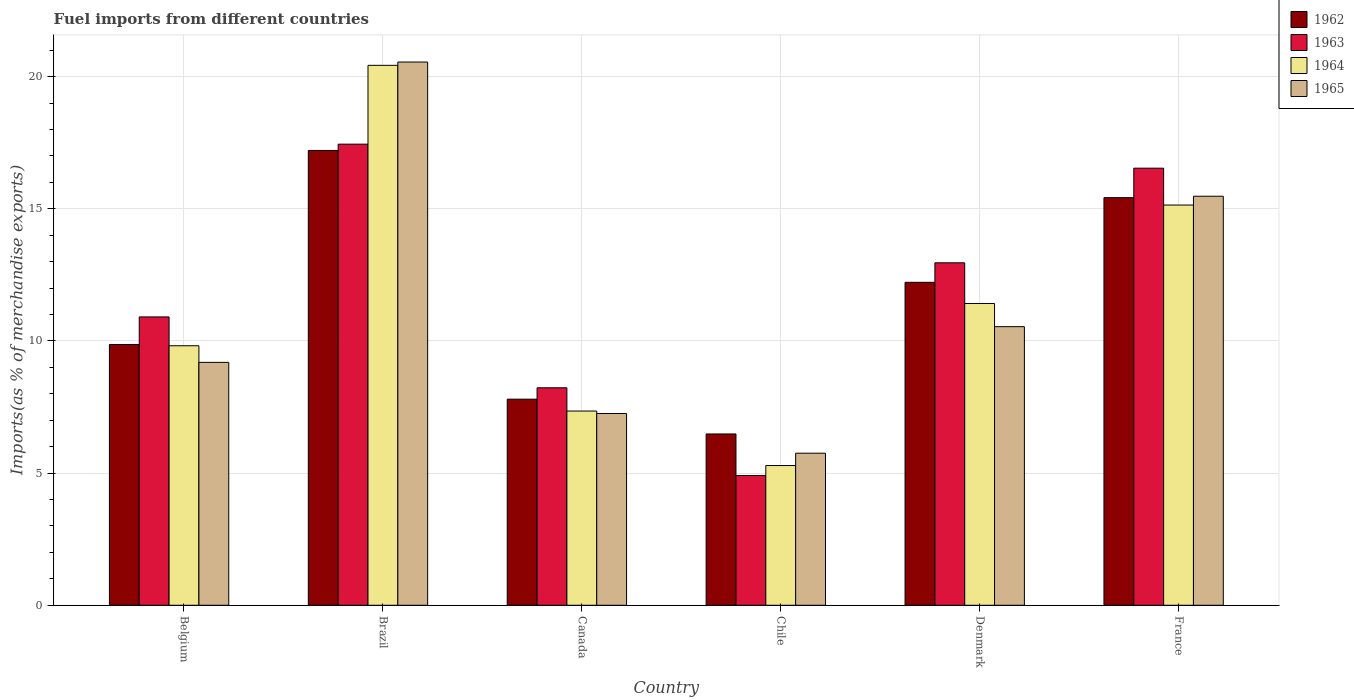How many different coloured bars are there?
Your answer should be compact. 4. Are the number of bars per tick equal to the number of legend labels?
Make the answer very short. Yes. How many bars are there on the 3rd tick from the left?
Your answer should be very brief. 4. What is the percentage of imports to different countries in 1964 in Brazil?
Offer a terse response. 20.43. Across all countries, what is the maximum percentage of imports to different countries in 1964?
Your answer should be very brief. 20.43. Across all countries, what is the minimum percentage of imports to different countries in 1962?
Give a very brief answer. 6.48. In which country was the percentage of imports to different countries in 1965 minimum?
Keep it short and to the point. Chile. What is the total percentage of imports to different countries in 1962 in the graph?
Offer a very short reply. 69. What is the difference between the percentage of imports to different countries in 1965 in Chile and that in France?
Your response must be concise. -9.72. What is the difference between the percentage of imports to different countries in 1963 in France and the percentage of imports to different countries in 1962 in Belgium?
Offer a very short reply. 6.67. What is the average percentage of imports to different countries in 1965 per country?
Offer a very short reply. 11.46. What is the difference between the percentage of imports to different countries of/in 1964 and percentage of imports to different countries of/in 1962 in Chile?
Provide a short and direct response. -1.19. What is the ratio of the percentage of imports to different countries in 1965 in Canada to that in France?
Provide a succinct answer. 0.47. Is the difference between the percentage of imports to different countries in 1964 in Belgium and Canada greater than the difference between the percentage of imports to different countries in 1962 in Belgium and Canada?
Make the answer very short. Yes. What is the difference between the highest and the second highest percentage of imports to different countries in 1962?
Provide a short and direct response. 4.99. What is the difference between the highest and the lowest percentage of imports to different countries in 1964?
Provide a succinct answer. 15.14. In how many countries, is the percentage of imports to different countries in 1963 greater than the average percentage of imports to different countries in 1963 taken over all countries?
Offer a terse response. 3. What does the 3rd bar from the left in Belgium represents?
Ensure brevity in your answer.  1964. What does the 2nd bar from the right in Canada represents?
Offer a very short reply. 1964. Is it the case that in every country, the sum of the percentage of imports to different countries in 1962 and percentage of imports to different countries in 1965 is greater than the percentage of imports to different countries in 1964?
Give a very brief answer. Yes. How many bars are there?
Your answer should be very brief. 24. Are all the bars in the graph horizontal?
Provide a short and direct response. No. How many countries are there in the graph?
Your answer should be compact. 6. Does the graph contain any zero values?
Your response must be concise. No. Does the graph contain grids?
Keep it short and to the point. Yes. Where does the legend appear in the graph?
Your answer should be very brief. Top right. How are the legend labels stacked?
Keep it short and to the point. Vertical. What is the title of the graph?
Keep it short and to the point. Fuel imports from different countries. Does "1991" appear as one of the legend labels in the graph?
Provide a succinct answer. No. What is the label or title of the Y-axis?
Give a very brief answer. Imports(as % of merchandise exports). What is the Imports(as % of merchandise exports) in 1962 in Belgium?
Offer a terse response. 9.87. What is the Imports(as % of merchandise exports) in 1963 in Belgium?
Keep it short and to the point. 10.91. What is the Imports(as % of merchandise exports) in 1964 in Belgium?
Keep it short and to the point. 9.82. What is the Imports(as % of merchandise exports) in 1965 in Belgium?
Keep it short and to the point. 9.19. What is the Imports(as % of merchandise exports) of 1962 in Brazil?
Offer a very short reply. 17.21. What is the Imports(as % of merchandise exports) of 1963 in Brazil?
Give a very brief answer. 17.45. What is the Imports(as % of merchandise exports) in 1964 in Brazil?
Make the answer very short. 20.43. What is the Imports(as % of merchandise exports) in 1965 in Brazil?
Give a very brief answer. 20.55. What is the Imports(as % of merchandise exports) in 1962 in Canada?
Offer a very short reply. 7.8. What is the Imports(as % of merchandise exports) in 1963 in Canada?
Keep it short and to the point. 8.23. What is the Imports(as % of merchandise exports) of 1964 in Canada?
Your answer should be very brief. 7.35. What is the Imports(as % of merchandise exports) of 1965 in Canada?
Your response must be concise. 7.26. What is the Imports(as % of merchandise exports) in 1962 in Chile?
Offer a terse response. 6.48. What is the Imports(as % of merchandise exports) in 1963 in Chile?
Keep it short and to the point. 4.91. What is the Imports(as % of merchandise exports) in 1964 in Chile?
Offer a terse response. 5.29. What is the Imports(as % of merchandise exports) in 1965 in Chile?
Provide a succinct answer. 5.75. What is the Imports(as % of merchandise exports) in 1962 in Denmark?
Your response must be concise. 12.22. What is the Imports(as % of merchandise exports) in 1963 in Denmark?
Your answer should be very brief. 12.96. What is the Imports(as % of merchandise exports) in 1964 in Denmark?
Your answer should be very brief. 11.42. What is the Imports(as % of merchandise exports) in 1965 in Denmark?
Your answer should be very brief. 10.54. What is the Imports(as % of merchandise exports) of 1962 in France?
Make the answer very short. 15.42. What is the Imports(as % of merchandise exports) in 1963 in France?
Make the answer very short. 16.54. What is the Imports(as % of merchandise exports) in 1964 in France?
Give a very brief answer. 15.14. What is the Imports(as % of merchandise exports) of 1965 in France?
Provide a short and direct response. 15.48. Across all countries, what is the maximum Imports(as % of merchandise exports) in 1962?
Give a very brief answer. 17.21. Across all countries, what is the maximum Imports(as % of merchandise exports) in 1963?
Offer a very short reply. 17.45. Across all countries, what is the maximum Imports(as % of merchandise exports) of 1964?
Your response must be concise. 20.43. Across all countries, what is the maximum Imports(as % of merchandise exports) of 1965?
Provide a succinct answer. 20.55. Across all countries, what is the minimum Imports(as % of merchandise exports) in 1962?
Keep it short and to the point. 6.48. Across all countries, what is the minimum Imports(as % of merchandise exports) of 1963?
Offer a terse response. 4.91. Across all countries, what is the minimum Imports(as % of merchandise exports) of 1964?
Give a very brief answer. 5.29. Across all countries, what is the minimum Imports(as % of merchandise exports) in 1965?
Make the answer very short. 5.75. What is the total Imports(as % of merchandise exports) of 1962 in the graph?
Provide a short and direct response. 69. What is the total Imports(as % of merchandise exports) of 1963 in the graph?
Offer a terse response. 70.99. What is the total Imports(as % of merchandise exports) of 1964 in the graph?
Ensure brevity in your answer.  69.45. What is the total Imports(as % of merchandise exports) of 1965 in the graph?
Provide a succinct answer. 68.77. What is the difference between the Imports(as % of merchandise exports) in 1962 in Belgium and that in Brazil?
Your answer should be compact. -7.34. What is the difference between the Imports(as % of merchandise exports) of 1963 in Belgium and that in Brazil?
Provide a short and direct response. -6.54. What is the difference between the Imports(as % of merchandise exports) in 1964 in Belgium and that in Brazil?
Keep it short and to the point. -10.61. What is the difference between the Imports(as % of merchandise exports) of 1965 in Belgium and that in Brazil?
Your answer should be very brief. -11.36. What is the difference between the Imports(as % of merchandise exports) of 1962 in Belgium and that in Canada?
Provide a succinct answer. 2.07. What is the difference between the Imports(as % of merchandise exports) of 1963 in Belgium and that in Canada?
Give a very brief answer. 2.68. What is the difference between the Imports(as % of merchandise exports) of 1964 in Belgium and that in Canada?
Your response must be concise. 2.47. What is the difference between the Imports(as % of merchandise exports) in 1965 in Belgium and that in Canada?
Ensure brevity in your answer.  1.93. What is the difference between the Imports(as % of merchandise exports) in 1962 in Belgium and that in Chile?
Provide a succinct answer. 3.39. What is the difference between the Imports(as % of merchandise exports) of 1963 in Belgium and that in Chile?
Give a very brief answer. 6. What is the difference between the Imports(as % of merchandise exports) in 1964 in Belgium and that in Chile?
Make the answer very short. 4.53. What is the difference between the Imports(as % of merchandise exports) in 1965 in Belgium and that in Chile?
Keep it short and to the point. 3.44. What is the difference between the Imports(as % of merchandise exports) of 1962 in Belgium and that in Denmark?
Provide a short and direct response. -2.35. What is the difference between the Imports(as % of merchandise exports) in 1963 in Belgium and that in Denmark?
Give a very brief answer. -2.05. What is the difference between the Imports(as % of merchandise exports) of 1964 in Belgium and that in Denmark?
Keep it short and to the point. -1.6. What is the difference between the Imports(as % of merchandise exports) of 1965 in Belgium and that in Denmark?
Ensure brevity in your answer.  -1.35. What is the difference between the Imports(as % of merchandise exports) of 1962 in Belgium and that in France?
Your response must be concise. -5.56. What is the difference between the Imports(as % of merchandise exports) of 1963 in Belgium and that in France?
Ensure brevity in your answer.  -5.63. What is the difference between the Imports(as % of merchandise exports) in 1964 in Belgium and that in France?
Offer a terse response. -5.32. What is the difference between the Imports(as % of merchandise exports) of 1965 in Belgium and that in France?
Provide a succinct answer. -6.29. What is the difference between the Imports(as % of merchandise exports) of 1962 in Brazil and that in Canada?
Your answer should be very brief. 9.41. What is the difference between the Imports(as % of merchandise exports) in 1963 in Brazil and that in Canada?
Provide a succinct answer. 9.22. What is the difference between the Imports(as % of merchandise exports) in 1964 in Brazil and that in Canada?
Offer a terse response. 13.08. What is the difference between the Imports(as % of merchandise exports) of 1965 in Brazil and that in Canada?
Your answer should be compact. 13.3. What is the difference between the Imports(as % of merchandise exports) in 1962 in Brazil and that in Chile?
Your response must be concise. 10.73. What is the difference between the Imports(as % of merchandise exports) in 1963 in Brazil and that in Chile?
Keep it short and to the point. 12.54. What is the difference between the Imports(as % of merchandise exports) in 1964 in Brazil and that in Chile?
Ensure brevity in your answer.  15.14. What is the difference between the Imports(as % of merchandise exports) in 1965 in Brazil and that in Chile?
Keep it short and to the point. 14.8. What is the difference between the Imports(as % of merchandise exports) in 1962 in Brazil and that in Denmark?
Your response must be concise. 4.99. What is the difference between the Imports(as % of merchandise exports) of 1963 in Brazil and that in Denmark?
Offer a very short reply. 4.49. What is the difference between the Imports(as % of merchandise exports) of 1964 in Brazil and that in Denmark?
Offer a very short reply. 9.01. What is the difference between the Imports(as % of merchandise exports) in 1965 in Brazil and that in Denmark?
Provide a short and direct response. 10.01. What is the difference between the Imports(as % of merchandise exports) in 1962 in Brazil and that in France?
Your answer should be compact. 1.79. What is the difference between the Imports(as % of merchandise exports) of 1963 in Brazil and that in France?
Offer a terse response. 0.91. What is the difference between the Imports(as % of merchandise exports) in 1964 in Brazil and that in France?
Keep it short and to the point. 5.29. What is the difference between the Imports(as % of merchandise exports) in 1965 in Brazil and that in France?
Offer a terse response. 5.08. What is the difference between the Imports(as % of merchandise exports) in 1962 in Canada and that in Chile?
Your response must be concise. 1.32. What is the difference between the Imports(as % of merchandise exports) of 1963 in Canada and that in Chile?
Give a very brief answer. 3.32. What is the difference between the Imports(as % of merchandise exports) in 1964 in Canada and that in Chile?
Make the answer very short. 2.06. What is the difference between the Imports(as % of merchandise exports) of 1965 in Canada and that in Chile?
Provide a succinct answer. 1.5. What is the difference between the Imports(as % of merchandise exports) of 1962 in Canada and that in Denmark?
Make the answer very short. -4.42. What is the difference between the Imports(as % of merchandise exports) in 1963 in Canada and that in Denmark?
Offer a very short reply. -4.73. What is the difference between the Imports(as % of merchandise exports) in 1964 in Canada and that in Denmark?
Give a very brief answer. -4.07. What is the difference between the Imports(as % of merchandise exports) of 1965 in Canada and that in Denmark?
Offer a terse response. -3.29. What is the difference between the Imports(as % of merchandise exports) of 1962 in Canada and that in France?
Ensure brevity in your answer.  -7.62. What is the difference between the Imports(as % of merchandise exports) in 1963 in Canada and that in France?
Your response must be concise. -8.31. What is the difference between the Imports(as % of merchandise exports) of 1964 in Canada and that in France?
Offer a terse response. -7.79. What is the difference between the Imports(as % of merchandise exports) of 1965 in Canada and that in France?
Your response must be concise. -8.22. What is the difference between the Imports(as % of merchandise exports) in 1962 in Chile and that in Denmark?
Your response must be concise. -5.74. What is the difference between the Imports(as % of merchandise exports) of 1963 in Chile and that in Denmark?
Provide a succinct answer. -8.05. What is the difference between the Imports(as % of merchandise exports) of 1964 in Chile and that in Denmark?
Keep it short and to the point. -6.13. What is the difference between the Imports(as % of merchandise exports) of 1965 in Chile and that in Denmark?
Offer a very short reply. -4.79. What is the difference between the Imports(as % of merchandise exports) in 1962 in Chile and that in France?
Give a very brief answer. -8.94. What is the difference between the Imports(as % of merchandise exports) in 1963 in Chile and that in France?
Give a very brief answer. -11.63. What is the difference between the Imports(as % of merchandise exports) of 1964 in Chile and that in France?
Make the answer very short. -9.86. What is the difference between the Imports(as % of merchandise exports) in 1965 in Chile and that in France?
Keep it short and to the point. -9.72. What is the difference between the Imports(as % of merchandise exports) in 1962 in Denmark and that in France?
Keep it short and to the point. -3.2. What is the difference between the Imports(as % of merchandise exports) of 1963 in Denmark and that in France?
Your answer should be compact. -3.58. What is the difference between the Imports(as % of merchandise exports) in 1964 in Denmark and that in France?
Keep it short and to the point. -3.72. What is the difference between the Imports(as % of merchandise exports) in 1965 in Denmark and that in France?
Provide a succinct answer. -4.94. What is the difference between the Imports(as % of merchandise exports) in 1962 in Belgium and the Imports(as % of merchandise exports) in 1963 in Brazil?
Ensure brevity in your answer.  -7.58. What is the difference between the Imports(as % of merchandise exports) in 1962 in Belgium and the Imports(as % of merchandise exports) in 1964 in Brazil?
Offer a terse response. -10.56. What is the difference between the Imports(as % of merchandise exports) in 1962 in Belgium and the Imports(as % of merchandise exports) in 1965 in Brazil?
Offer a terse response. -10.69. What is the difference between the Imports(as % of merchandise exports) of 1963 in Belgium and the Imports(as % of merchandise exports) of 1964 in Brazil?
Make the answer very short. -9.52. What is the difference between the Imports(as % of merchandise exports) of 1963 in Belgium and the Imports(as % of merchandise exports) of 1965 in Brazil?
Ensure brevity in your answer.  -9.64. What is the difference between the Imports(as % of merchandise exports) in 1964 in Belgium and the Imports(as % of merchandise exports) in 1965 in Brazil?
Your answer should be very brief. -10.74. What is the difference between the Imports(as % of merchandise exports) in 1962 in Belgium and the Imports(as % of merchandise exports) in 1963 in Canada?
Ensure brevity in your answer.  1.64. What is the difference between the Imports(as % of merchandise exports) of 1962 in Belgium and the Imports(as % of merchandise exports) of 1964 in Canada?
Offer a very short reply. 2.52. What is the difference between the Imports(as % of merchandise exports) in 1962 in Belgium and the Imports(as % of merchandise exports) in 1965 in Canada?
Offer a very short reply. 2.61. What is the difference between the Imports(as % of merchandise exports) of 1963 in Belgium and the Imports(as % of merchandise exports) of 1964 in Canada?
Your answer should be compact. 3.56. What is the difference between the Imports(as % of merchandise exports) of 1963 in Belgium and the Imports(as % of merchandise exports) of 1965 in Canada?
Provide a short and direct response. 3.65. What is the difference between the Imports(as % of merchandise exports) in 1964 in Belgium and the Imports(as % of merchandise exports) in 1965 in Canada?
Your answer should be compact. 2.56. What is the difference between the Imports(as % of merchandise exports) of 1962 in Belgium and the Imports(as % of merchandise exports) of 1963 in Chile?
Your answer should be compact. 4.96. What is the difference between the Imports(as % of merchandise exports) in 1962 in Belgium and the Imports(as % of merchandise exports) in 1964 in Chile?
Ensure brevity in your answer.  4.58. What is the difference between the Imports(as % of merchandise exports) in 1962 in Belgium and the Imports(as % of merchandise exports) in 1965 in Chile?
Ensure brevity in your answer.  4.11. What is the difference between the Imports(as % of merchandise exports) in 1963 in Belgium and the Imports(as % of merchandise exports) in 1964 in Chile?
Provide a short and direct response. 5.62. What is the difference between the Imports(as % of merchandise exports) of 1963 in Belgium and the Imports(as % of merchandise exports) of 1965 in Chile?
Your answer should be compact. 5.16. What is the difference between the Imports(as % of merchandise exports) in 1964 in Belgium and the Imports(as % of merchandise exports) in 1965 in Chile?
Your answer should be compact. 4.07. What is the difference between the Imports(as % of merchandise exports) in 1962 in Belgium and the Imports(as % of merchandise exports) in 1963 in Denmark?
Give a very brief answer. -3.09. What is the difference between the Imports(as % of merchandise exports) of 1962 in Belgium and the Imports(as % of merchandise exports) of 1964 in Denmark?
Provide a short and direct response. -1.55. What is the difference between the Imports(as % of merchandise exports) in 1962 in Belgium and the Imports(as % of merchandise exports) in 1965 in Denmark?
Provide a short and direct response. -0.67. What is the difference between the Imports(as % of merchandise exports) of 1963 in Belgium and the Imports(as % of merchandise exports) of 1964 in Denmark?
Make the answer very short. -0.51. What is the difference between the Imports(as % of merchandise exports) in 1963 in Belgium and the Imports(as % of merchandise exports) in 1965 in Denmark?
Ensure brevity in your answer.  0.37. What is the difference between the Imports(as % of merchandise exports) of 1964 in Belgium and the Imports(as % of merchandise exports) of 1965 in Denmark?
Keep it short and to the point. -0.72. What is the difference between the Imports(as % of merchandise exports) in 1962 in Belgium and the Imports(as % of merchandise exports) in 1963 in France?
Provide a short and direct response. -6.67. What is the difference between the Imports(as % of merchandise exports) of 1962 in Belgium and the Imports(as % of merchandise exports) of 1964 in France?
Your response must be concise. -5.28. What is the difference between the Imports(as % of merchandise exports) of 1962 in Belgium and the Imports(as % of merchandise exports) of 1965 in France?
Make the answer very short. -5.61. What is the difference between the Imports(as % of merchandise exports) in 1963 in Belgium and the Imports(as % of merchandise exports) in 1964 in France?
Make the answer very short. -4.23. What is the difference between the Imports(as % of merchandise exports) of 1963 in Belgium and the Imports(as % of merchandise exports) of 1965 in France?
Offer a very short reply. -4.57. What is the difference between the Imports(as % of merchandise exports) in 1964 in Belgium and the Imports(as % of merchandise exports) in 1965 in France?
Your response must be concise. -5.66. What is the difference between the Imports(as % of merchandise exports) in 1962 in Brazil and the Imports(as % of merchandise exports) in 1963 in Canada?
Keep it short and to the point. 8.98. What is the difference between the Imports(as % of merchandise exports) in 1962 in Brazil and the Imports(as % of merchandise exports) in 1964 in Canada?
Provide a short and direct response. 9.86. What is the difference between the Imports(as % of merchandise exports) in 1962 in Brazil and the Imports(as % of merchandise exports) in 1965 in Canada?
Offer a terse response. 9.95. What is the difference between the Imports(as % of merchandise exports) in 1963 in Brazil and the Imports(as % of merchandise exports) in 1964 in Canada?
Offer a terse response. 10.1. What is the difference between the Imports(as % of merchandise exports) of 1963 in Brazil and the Imports(as % of merchandise exports) of 1965 in Canada?
Make the answer very short. 10.19. What is the difference between the Imports(as % of merchandise exports) in 1964 in Brazil and the Imports(as % of merchandise exports) in 1965 in Canada?
Your answer should be compact. 13.17. What is the difference between the Imports(as % of merchandise exports) in 1962 in Brazil and the Imports(as % of merchandise exports) in 1963 in Chile?
Give a very brief answer. 12.3. What is the difference between the Imports(as % of merchandise exports) in 1962 in Brazil and the Imports(as % of merchandise exports) in 1964 in Chile?
Your answer should be compact. 11.92. What is the difference between the Imports(as % of merchandise exports) of 1962 in Brazil and the Imports(as % of merchandise exports) of 1965 in Chile?
Offer a terse response. 11.46. What is the difference between the Imports(as % of merchandise exports) of 1963 in Brazil and the Imports(as % of merchandise exports) of 1964 in Chile?
Make the answer very short. 12.16. What is the difference between the Imports(as % of merchandise exports) in 1963 in Brazil and the Imports(as % of merchandise exports) in 1965 in Chile?
Ensure brevity in your answer.  11.69. What is the difference between the Imports(as % of merchandise exports) in 1964 in Brazil and the Imports(as % of merchandise exports) in 1965 in Chile?
Your response must be concise. 14.68. What is the difference between the Imports(as % of merchandise exports) in 1962 in Brazil and the Imports(as % of merchandise exports) in 1963 in Denmark?
Offer a terse response. 4.25. What is the difference between the Imports(as % of merchandise exports) in 1962 in Brazil and the Imports(as % of merchandise exports) in 1964 in Denmark?
Keep it short and to the point. 5.79. What is the difference between the Imports(as % of merchandise exports) in 1962 in Brazil and the Imports(as % of merchandise exports) in 1965 in Denmark?
Provide a succinct answer. 6.67. What is the difference between the Imports(as % of merchandise exports) of 1963 in Brazil and the Imports(as % of merchandise exports) of 1964 in Denmark?
Ensure brevity in your answer.  6.03. What is the difference between the Imports(as % of merchandise exports) in 1963 in Brazil and the Imports(as % of merchandise exports) in 1965 in Denmark?
Offer a terse response. 6.91. What is the difference between the Imports(as % of merchandise exports) in 1964 in Brazil and the Imports(as % of merchandise exports) in 1965 in Denmark?
Give a very brief answer. 9.89. What is the difference between the Imports(as % of merchandise exports) of 1962 in Brazil and the Imports(as % of merchandise exports) of 1963 in France?
Your response must be concise. 0.67. What is the difference between the Imports(as % of merchandise exports) of 1962 in Brazil and the Imports(as % of merchandise exports) of 1964 in France?
Your answer should be very brief. 2.07. What is the difference between the Imports(as % of merchandise exports) in 1962 in Brazil and the Imports(as % of merchandise exports) in 1965 in France?
Offer a terse response. 1.73. What is the difference between the Imports(as % of merchandise exports) in 1963 in Brazil and the Imports(as % of merchandise exports) in 1964 in France?
Give a very brief answer. 2.3. What is the difference between the Imports(as % of merchandise exports) in 1963 in Brazil and the Imports(as % of merchandise exports) in 1965 in France?
Keep it short and to the point. 1.97. What is the difference between the Imports(as % of merchandise exports) of 1964 in Brazil and the Imports(as % of merchandise exports) of 1965 in France?
Your answer should be very brief. 4.95. What is the difference between the Imports(as % of merchandise exports) of 1962 in Canada and the Imports(as % of merchandise exports) of 1963 in Chile?
Ensure brevity in your answer.  2.89. What is the difference between the Imports(as % of merchandise exports) in 1962 in Canada and the Imports(as % of merchandise exports) in 1964 in Chile?
Make the answer very short. 2.51. What is the difference between the Imports(as % of merchandise exports) in 1962 in Canada and the Imports(as % of merchandise exports) in 1965 in Chile?
Provide a succinct answer. 2.04. What is the difference between the Imports(as % of merchandise exports) of 1963 in Canada and the Imports(as % of merchandise exports) of 1964 in Chile?
Your answer should be very brief. 2.94. What is the difference between the Imports(as % of merchandise exports) in 1963 in Canada and the Imports(as % of merchandise exports) in 1965 in Chile?
Your answer should be compact. 2.48. What is the difference between the Imports(as % of merchandise exports) in 1964 in Canada and the Imports(as % of merchandise exports) in 1965 in Chile?
Ensure brevity in your answer.  1.6. What is the difference between the Imports(as % of merchandise exports) of 1962 in Canada and the Imports(as % of merchandise exports) of 1963 in Denmark?
Your answer should be compact. -5.16. What is the difference between the Imports(as % of merchandise exports) of 1962 in Canada and the Imports(as % of merchandise exports) of 1964 in Denmark?
Offer a terse response. -3.62. What is the difference between the Imports(as % of merchandise exports) in 1962 in Canada and the Imports(as % of merchandise exports) in 1965 in Denmark?
Offer a very short reply. -2.74. What is the difference between the Imports(as % of merchandise exports) of 1963 in Canada and the Imports(as % of merchandise exports) of 1964 in Denmark?
Your answer should be very brief. -3.19. What is the difference between the Imports(as % of merchandise exports) in 1963 in Canada and the Imports(as % of merchandise exports) in 1965 in Denmark?
Provide a succinct answer. -2.31. What is the difference between the Imports(as % of merchandise exports) in 1964 in Canada and the Imports(as % of merchandise exports) in 1965 in Denmark?
Give a very brief answer. -3.19. What is the difference between the Imports(as % of merchandise exports) of 1962 in Canada and the Imports(as % of merchandise exports) of 1963 in France?
Provide a short and direct response. -8.74. What is the difference between the Imports(as % of merchandise exports) in 1962 in Canada and the Imports(as % of merchandise exports) in 1964 in France?
Give a very brief answer. -7.35. What is the difference between the Imports(as % of merchandise exports) in 1962 in Canada and the Imports(as % of merchandise exports) in 1965 in France?
Your answer should be compact. -7.68. What is the difference between the Imports(as % of merchandise exports) of 1963 in Canada and the Imports(as % of merchandise exports) of 1964 in France?
Offer a very short reply. -6.91. What is the difference between the Imports(as % of merchandise exports) of 1963 in Canada and the Imports(as % of merchandise exports) of 1965 in France?
Make the answer very short. -7.25. What is the difference between the Imports(as % of merchandise exports) of 1964 in Canada and the Imports(as % of merchandise exports) of 1965 in France?
Offer a terse response. -8.13. What is the difference between the Imports(as % of merchandise exports) in 1962 in Chile and the Imports(as % of merchandise exports) in 1963 in Denmark?
Provide a succinct answer. -6.48. What is the difference between the Imports(as % of merchandise exports) in 1962 in Chile and the Imports(as % of merchandise exports) in 1964 in Denmark?
Ensure brevity in your answer.  -4.94. What is the difference between the Imports(as % of merchandise exports) in 1962 in Chile and the Imports(as % of merchandise exports) in 1965 in Denmark?
Offer a very short reply. -4.06. What is the difference between the Imports(as % of merchandise exports) in 1963 in Chile and the Imports(as % of merchandise exports) in 1964 in Denmark?
Provide a succinct answer. -6.51. What is the difference between the Imports(as % of merchandise exports) of 1963 in Chile and the Imports(as % of merchandise exports) of 1965 in Denmark?
Your answer should be very brief. -5.63. What is the difference between the Imports(as % of merchandise exports) in 1964 in Chile and the Imports(as % of merchandise exports) in 1965 in Denmark?
Provide a succinct answer. -5.25. What is the difference between the Imports(as % of merchandise exports) in 1962 in Chile and the Imports(as % of merchandise exports) in 1963 in France?
Offer a terse response. -10.06. What is the difference between the Imports(as % of merchandise exports) of 1962 in Chile and the Imports(as % of merchandise exports) of 1964 in France?
Provide a succinct answer. -8.66. What is the difference between the Imports(as % of merchandise exports) of 1962 in Chile and the Imports(as % of merchandise exports) of 1965 in France?
Give a very brief answer. -9. What is the difference between the Imports(as % of merchandise exports) of 1963 in Chile and the Imports(as % of merchandise exports) of 1964 in France?
Your answer should be very brief. -10.23. What is the difference between the Imports(as % of merchandise exports) of 1963 in Chile and the Imports(as % of merchandise exports) of 1965 in France?
Ensure brevity in your answer.  -10.57. What is the difference between the Imports(as % of merchandise exports) in 1964 in Chile and the Imports(as % of merchandise exports) in 1965 in France?
Make the answer very short. -10.19. What is the difference between the Imports(as % of merchandise exports) of 1962 in Denmark and the Imports(as % of merchandise exports) of 1963 in France?
Keep it short and to the point. -4.32. What is the difference between the Imports(as % of merchandise exports) in 1962 in Denmark and the Imports(as % of merchandise exports) in 1964 in France?
Your answer should be compact. -2.92. What is the difference between the Imports(as % of merchandise exports) in 1962 in Denmark and the Imports(as % of merchandise exports) in 1965 in France?
Your answer should be very brief. -3.26. What is the difference between the Imports(as % of merchandise exports) of 1963 in Denmark and the Imports(as % of merchandise exports) of 1964 in France?
Make the answer very short. -2.19. What is the difference between the Imports(as % of merchandise exports) of 1963 in Denmark and the Imports(as % of merchandise exports) of 1965 in France?
Provide a succinct answer. -2.52. What is the difference between the Imports(as % of merchandise exports) in 1964 in Denmark and the Imports(as % of merchandise exports) in 1965 in France?
Make the answer very short. -4.06. What is the average Imports(as % of merchandise exports) in 1962 per country?
Your answer should be very brief. 11.5. What is the average Imports(as % of merchandise exports) in 1963 per country?
Your answer should be very brief. 11.83. What is the average Imports(as % of merchandise exports) of 1964 per country?
Ensure brevity in your answer.  11.57. What is the average Imports(as % of merchandise exports) in 1965 per country?
Your response must be concise. 11.46. What is the difference between the Imports(as % of merchandise exports) in 1962 and Imports(as % of merchandise exports) in 1963 in Belgium?
Provide a short and direct response. -1.04. What is the difference between the Imports(as % of merchandise exports) in 1962 and Imports(as % of merchandise exports) in 1964 in Belgium?
Give a very brief answer. 0.05. What is the difference between the Imports(as % of merchandise exports) of 1962 and Imports(as % of merchandise exports) of 1965 in Belgium?
Offer a very short reply. 0.68. What is the difference between the Imports(as % of merchandise exports) of 1963 and Imports(as % of merchandise exports) of 1964 in Belgium?
Provide a succinct answer. 1.09. What is the difference between the Imports(as % of merchandise exports) in 1963 and Imports(as % of merchandise exports) in 1965 in Belgium?
Ensure brevity in your answer.  1.72. What is the difference between the Imports(as % of merchandise exports) of 1964 and Imports(as % of merchandise exports) of 1965 in Belgium?
Offer a terse response. 0.63. What is the difference between the Imports(as % of merchandise exports) in 1962 and Imports(as % of merchandise exports) in 1963 in Brazil?
Your response must be concise. -0.24. What is the difference between the Imports(as % of merchandise exports) in 1962 and Imports(as % of merchandise exports) in 1964 in Brazil?
Make the answer very short. -3.22. What is the difference between the Imports(as % of merchandise exports) in 1962 and Imports(as % of merchandise exports) in 1965 in Brazil?
Make the answer very short. -3.35. What is the difference between the Imports(as % of merchandise exports) in 1963 and Imports(as % of merchandise exports) in 1964 in Brazil?
Make the answer very short. -2.98. What is the difference between the Imports(as % of merchandise exports) of 1963 and Imports(as % of merchandise exports) of 1965 in Brazil?
Offer a terse response. -3.11. What is the difference between the Imports(as % of merchandise exports) in 1964 and Imports(as % of merchandise exports) in 1965 in Brazil?
Give a very brief answer. -0.12. What is the difference between the Imports(as % of merchandise exports) of 1962 and Imports(as % of merchandise exports) of 1963 in Canada?
Ensure brevity in your answer.  -0.43. What is the difference between the Imports(as % of merchandise exports) in 1962 and Imports(as % of merchandise exports) in 1964 in Canada?
Your response must be concise. 0.45. What is the difference between the Imports(as % of merchandise exports) in 1962 and Imports(as % of merchandise exports) in 1965 in Canada?
Offer a very short reply. 0.54. What is the difference between the Imports(as % of merchandise exports) in 1963 and Imports(as % of merchandise exports) in 1964 in Canada?
Keep it short and to the point. 0.88. What is the difference between the Imports(as % of merchandise exports) in 1963 and Imports(as % of merchandise exports) in 1965 in Canada?
Provide a succinct answer. 0.97. What is the difference between the Imports(as % of merchandise exports) of 1964 and Imports(as % of merchandise exports) of 1965 in Canada?
Make the answer very short. 0.09. What is the difference between the Imports(as % of merchandise exports) in 1962 and Imports(as % of merchandise exports) in 1963 in Chile?
Give a very brief answer. 1.57. What is the difference between the Imports(as % of merchandise exports) in 1962 and Imports(as % of merchandise exports) in 1964 in Chile?
Provide a short and direct response. 1.19. What is the difference between the Imports(as % of merchandise exports) in 1962 and Imports(as % of merchandise exports) in 1965 in Chile?
Keep it short and to the point. 0.73. What is the difference between the Imports(as % of merchandise exports) of 1963 and Imports(as % of merchandise exports) of 1964 in Chile?
Provide a succinct answer. -0.38. What is the difference between the Imports(as % of merchandise exports) of 1963 and Imports(as % of merchandise exports) of 1965 in Chile?
Give a very brief answer. -0.84. What is the difference between the Imports(as % of merchandise exports) in 1964 and Imports(as % of merchandise exports) in 1965 in Chile?
Your response must be concise. -0.47. What is the difference between the Imports(as % of merchandise exports) in 1962 and Imports(as % of merchandise exports) in 1963 in Denmark?
Your answer should be very brief. -0.74. What is the difference between the Imports(as % of merchandise exports) in 1962 and Imports(as % of merchandise exports) in 1964 in Denmark?
Your answer should be compact. 0.8. What is the difference between the Imports(as % of merchandise exports) in 1962 and Imports(as % of merchandise exports) in 1965 in Denmark?
Offer a terse response. 1.68. What is the difference between the Imports(as % of merchandise exports) of 1963 and Imports(as % of merchandise exports) of 1964 in Denmark?
Offer a terse response. 1.54. What is the difference between the Imports(as % of merchandise exports) of 1963 and Imports(as % of merchandise exports) of 1965 in Denmark?
Keep it short and to the point. 2.42. What is the difference between the Imports(as % of merchandise exports) of 1964 and Imports(as % of merchandise exports) of 1965 in Denmark?
Your answer should be compact. 0.88. What is the difference between the Imports(as % of merchandise exports) of 1962 and Imports(as % of merchandise exports) of 1963 in France?
Give a very brief answer. -1.12. What is the difference between the Imports(as % of merchandise exports) of 1962 and Imports(as % of merchandise exports) of 1964 in France?
Your answer should be compact. 0.28. What is the difference between the Imports(as % of merchandise exports) in 1962 and Imports(as % of merchandise exports) in 1965 in France?
Your response must be concise. -0.05. What is the difference between the Imports(as % of merchandise exports) in 1963 and Imports(as % of merchandise exports) in 1964 in France?
Offer a very short reply. 1.39. What is the difference between the Imports(as % of merchandise exports) of 1963 and Imports(as % of merchandise exports) of 1965 in France?
Provide a short and direct response. 1.06. What is the difference between the Imports(as % of merchandise exports) in 1964 and Imports(as % of merchandise exports) in 1965 in France?
Your answer should be compact. -0.33. What is the ratio of the Imports(as % of merchandise exports) of 1962 in Belgium to that in Brazil?
Offer a very short reply. 0.57. What is the ratio of the Imports(as % of merchandise exports) of 1963 in Belgium to that in Brazil?
Give a very brief answer. 0.63. What is the ratio of the Imports(as % of merchandise exports) in 1964 in Belgium to that in Brazil?
Ensure brevity in your answer.  0.48. What is the ratio of the Imports(as % of merchandise exports) of 1965 in Belgium to that in Brazil?
Offer a very short reply. 0.45. What is the ratio of the Imports(as % of merchandise exports) in 1962 in Belgium to that in Canada?
Make the answer very short. 1.27. What is the ratio of the Imports(as % of merchandise exports) in 1963 in Belgium to that in Canada?
Keep it short and to the point. 1.33. What is the ratio of the Imports(as % of merchandise exports) in 1964 in Belgium to that in Canada?
Your response must be concise. 1.34. What is the ratio of the Imports(as % of merchandise exports) in 1965 in Belgium to that in Canada?
Keep it short and to the point. 1.27. What is the ratio of the Imports(as % of merchandise exports) in 1962 in Belgium to that in Chile?
Offer a very short reply. 1.52. What is the ratio of the Imports(as % of merchandise exports) of 1963 in Belgium to that in Chile?
Your response must be concise. 2.22. What is the ratio of the Imports(as % of merchandise exports) of 1964 in Belgium to that in Chile?
Your response must be concise. 1.86. What is the ratio of the Imports(as % of merchandise exports) in 1965 in Belgium to that in Chile?
Your answer should be very brief. 1.6. What is the ratio of the Imports(as % of merchandise exports) in 1962 in Belgium to that in Denmark?
Offer a very short reply. 0.81. What is the ratio of the Imports(as % of merchandise exports) in 1963 in Belgium to that in Denmark?
Offer a terse response. 0.84. What is the ratio of the Imports(as % of merchandise exports) of 1964 in Belgium to that in Denmark?
Make the answer very short. 0.86. What is the ratio of the Imports(as % of merchandise exports) in 1965 in Belgium to that in Denmark?
Offer a very short reply. 0.87. What is the ratio of the Imports(as % of merchandise exports) of 1962 in Belgium to that in France?
Ensure brevity in your answer.  0.64. What is the ratio of the Imports(as % of merchandise exports) of 1963 in Belgium to that in France?
Keep it short and to the point. 0.66. What is the ratio of the Imports(as % of merchandise exports) of 1964 in Belgium to that in France?
Provide a short and direct response. 0.65. What is the ratio of the Imports(as % of merchandise exports) in 1965 in Belgium to that in France?
Offer a very short reply. 0.59. What is the ratio of the Imports(as % of merchandise exports) in 1962 in Brazil to that in Canada?
Your answer should be compact. 2.21. What is the ratio of the Imports(as % of merchandise exports) in 1963 in Brazil to that in Canada?
Give a very brief answer. 2.12. What is the ratio of the Imports(as % of merchandise exports) in 1964 in Brazil to that in Canada?
Give a very brief answer. 2.78. What is the ratio of the Imports(as % of merchandise exports) of 1965 in Brazil to that in Canada?
Ensure brevity in your answer.  2.83. What is the ratio of the Imports(as % of merchandise exports) in 1962 in Brazil to that in Chile?
Offer a very short reply. 2.65. What is the ratio of the Imports(as % of merchandise exports) in 1963 in Brazil to that in Chile?
Your response must be concise. 3.55. What is the ratio of the Imports(as % of merchandise exports) of 1964 in Brazil to that in Chile?
Give a very brief answer. 3.86. What is the ratio of the Imports(as % of merchandise exports) of 1965 in Brazil to that in Chile?
Provide a succinct answer. 3.57. What is the ratio of the Imports(as % of merchandise exports) in 1962 in Brazil to that in Denmark?
Keep it short and to the point. 1.41. What is the ratio of the Imports(as % of merchandise exports) of 1963 in Brazil to that in Denmark?
Give a very brief answer. 1.35. What is the ratio of the Imports(as % of merchandise exports) in 1964 in Brazil to that in Denmark?
Keep it short and to the point. 1.79. What is the ratio of the Imports(as % of merchandise exports) of 1965 in Brazil to that in Denmark?
Give a very brief answer. 1.95. What is the ratio of the Imports(as % of merchandise exports) in 1962 in Brazil to that in France?
Make the answer very short. 1.12. What is the ratio of the Imports(as % of merchandise exports) in 1963 in Brazil to that in France?
Provide a short and direct response. 1.05. What is the ratio of the Imports(as % of merchandise exports) of 1964 in Brazil to that in France?
Provide a short and direct response. 1.35. What is the ratio of the Imports(as % of merchandise exports) of 1965 in Brazil to that in France?
Keep it short and to the point. 1.33. What is the ratio of the Imports(as % of merchandise exports) of 1962 in Canada to that in Chile?
Provide a succinct answer. 1.2. What is the ratio of the Imports(as % of merchandise exports) of 1963 in Canada to that in Chile?
Make the answer very short. 1.68. What is the ratio of the Imports(as % of merchandise exports) of 1964 in Canada to that in Chile?
Your response must be concise. 1.39. What is the ratio of the Imports(as % of merchandise exports) of 1965 in Canada to that in Chile?
Provide a succinct answer. 1.26. What is the ratio of the Imports(as % of merchandise exports) of 1962 in Canada to that in Denmark?
Your response must be concise. 0.64. What is the ratio of the Imports(as % of merchandise exports) in 1963 in Canada to that in Denmark?
Ensure brevity in your answer.  0.64. What is the ratio of the Imports(as % of merchandise exports) of 1964 in Canada to that in Denmark?
Your answer should be compact. 0.64. What is the ratio of the Imports(as % of merchandise exports) in 1965 in Canada to that in Denmark?
Provide a succinct answer. 0.69. What is the ratio of the Imports(as % of merchandise exports) of 1962 in Canada to that in France?
Keep it short and to the point. 0.51. What is the ratio of the Imports(as % of merchandise exports) of 1963 in Canada to that in France?
Your response must be concise. 0.5. What is the ratio of the Imports(as % of merchandise exports) of 1964 in Canada to that in France?
Make the answer very short. 0.49. What is the ratio of the Imports(as % of merchandise exports) of 1965 in Canada to that in France?
Ensure brevity in your answer.  0.47. What is the ratio of the Imports(as % of merchandise exports) of 1962 in Chile to that in Denmark?
Provide a succinct answer. 0.53. What is the ratio of the Imports(as % of merchandise exports) of 1963 in Chile to that in Denmark?
Provide a short and direct response. 0.38. What is the ratio of the Imports(as % of merchandise exports) in 1964 in Chile to that in Denmark?
Make the answer very short. 0.46. What is the ratio of the Imports(as % of merchandise exports) in 1965 in Chile to that in Denmark?
Ensure brevity in your answer.  0.55. What is the ratio of the Imports(as % of merchandise exports) in 1962 in Chile to that in France?
Keep it short and to the point. 0.42. What is the ratio of the Imports(as % of merchandise exports) of 1963 in Chile to that in France?
Your answer should be compact. 0.3. What is the ratio of the Imports(as % of merchandise exports) of 1964 in Chile to that in France?
Offer a terse response. 0.35. What is the ratio of the Imports(as % of merchandise exports) of 1965 in Chile to that in France?
Provide a succinct answer. 0.37. What is the ratio of the Imports(as % of merchandise exports) of 1962 in Denmark to that in France?
Your answer should be compact. 0.79. What is the ratio of the Imports(as % of merchandise exports) in 1963 in Denmark to that in France?
Offer a terse response. 0.78. What is the ratio of the Imports(as % of merchandise exports) of 1964 in Denmark to that in France?
Your answer should be compact. 0.75. What is the ratio of the Imports(as % of merchandise exports) of 1965 in Denmark to that in France?
Keep it short and to the point. 0.68. What is the difference between the highest and the second highest Imports(as % of merchandise exports) in 1962?
Keep it short and to the point. 1.79. What is the difference between the highest and the second highest Imports(as % of merchandise exports) in 1963?
Your answer should be very brief. 0.91. What is the difference between the highest and the second highest Imports(as % of merchandise exports) in 1964?
Provide a short and direct response. 5.29. What is the difference between the highest and the second highest Imports(as % of merchandise exports) in 1965?
Give a very brief answer. 5.08. What is the difference between the highest and the lowest Imports(as % of merchandise exports) of 1962?
Ensure brevity in your answer.  10.73. What is the difference between the highest and the lowest Imports(as % of merchandise exports) of 1963?
Your answer should be very brief. 12.54. What is the difference between the highest and the lowest Imports(as % of merchandise exports) of 1964?
Your response must be concise. 15.14. What is the difference between the highest and the lowest Imports(as % of merchandise exports) in 1965?
Your answer should be very brief. 14.8. 